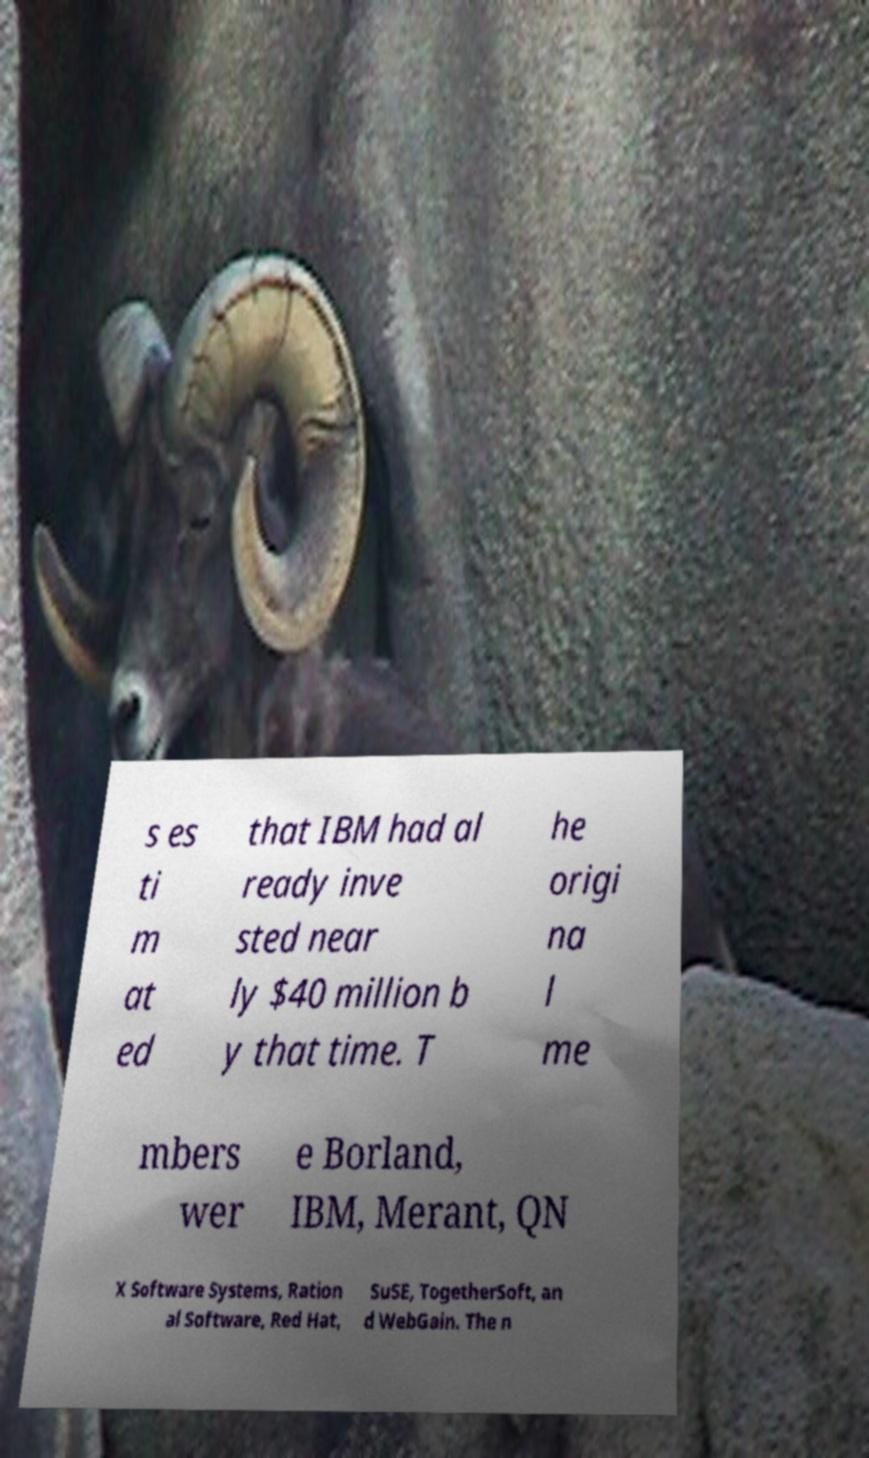Please identify and transcribe the text found in this image. s es ti m at ed that IBM had al ready inve sted near ly $40 million b y that time. T he origi na l me mbers wer e Borland, IBM, Merant, QN X Software Systems, Ration al Software, Red Hat, SuSE, TogetherSoft, an d WebGain. The n 